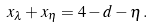Convert formula to latex. <formula><loc_0><loc_0><loc_500><loc_500>x _ { \lambda } + x _ { \eta } = 4 - d - \eta \, .</formula> 